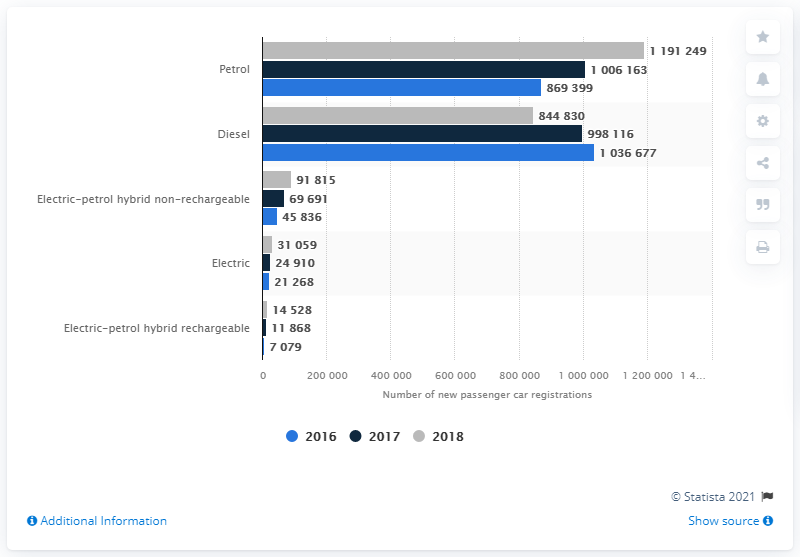Indicate a few pertinent items in this graphic. In 2017, a total of 100,616,345 petrol-fueled cars were sold in France. 